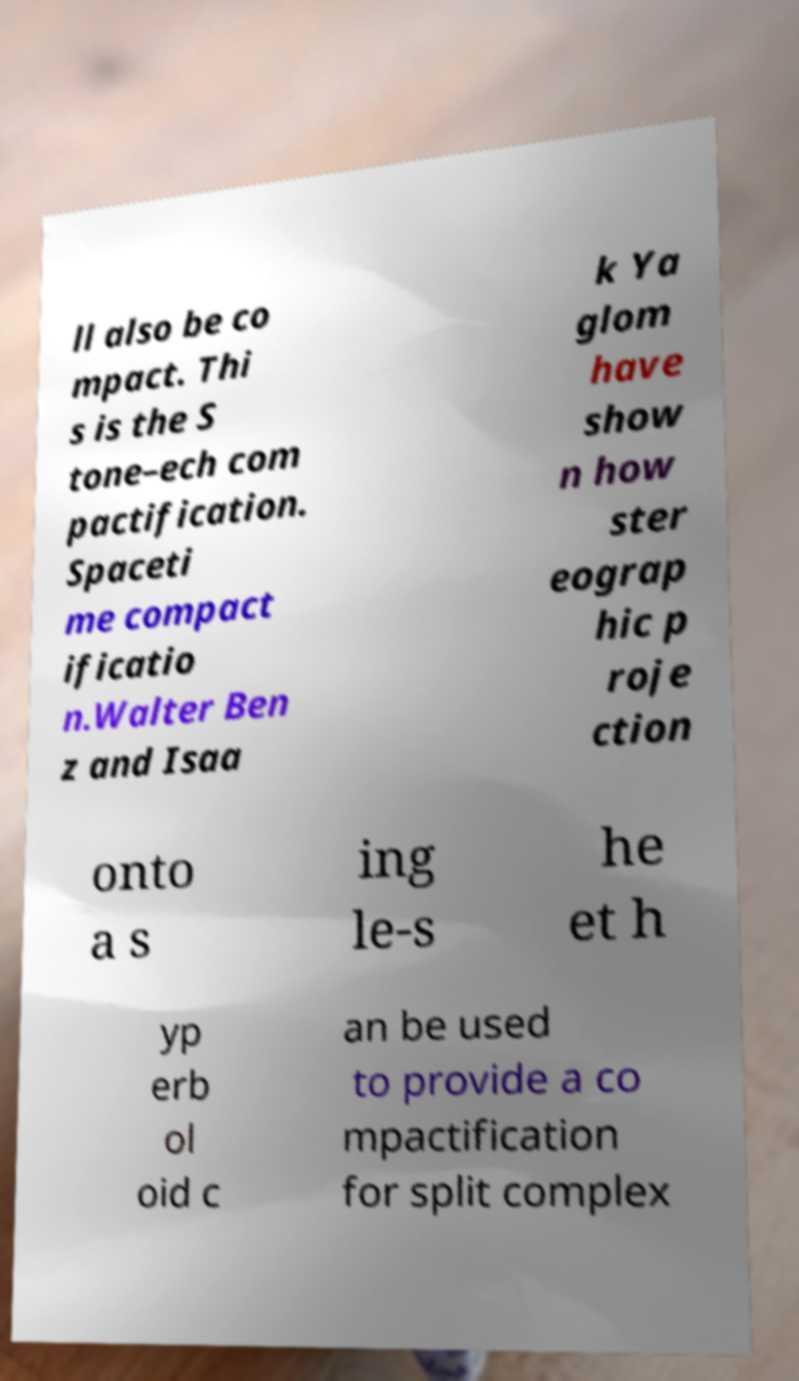I need the written content from this picture converted into text. Can you do that? ll also be co mpact. Thi s is the S tone–ech com pactification. Spaceti me compact ificatio n.Walter Ben z and Isaa k Ya glom have show n how ster eograp hic p roje ction onto a s ing le-s he et h yp erb ol oid c an be used to provide a co mpactification for split complex 